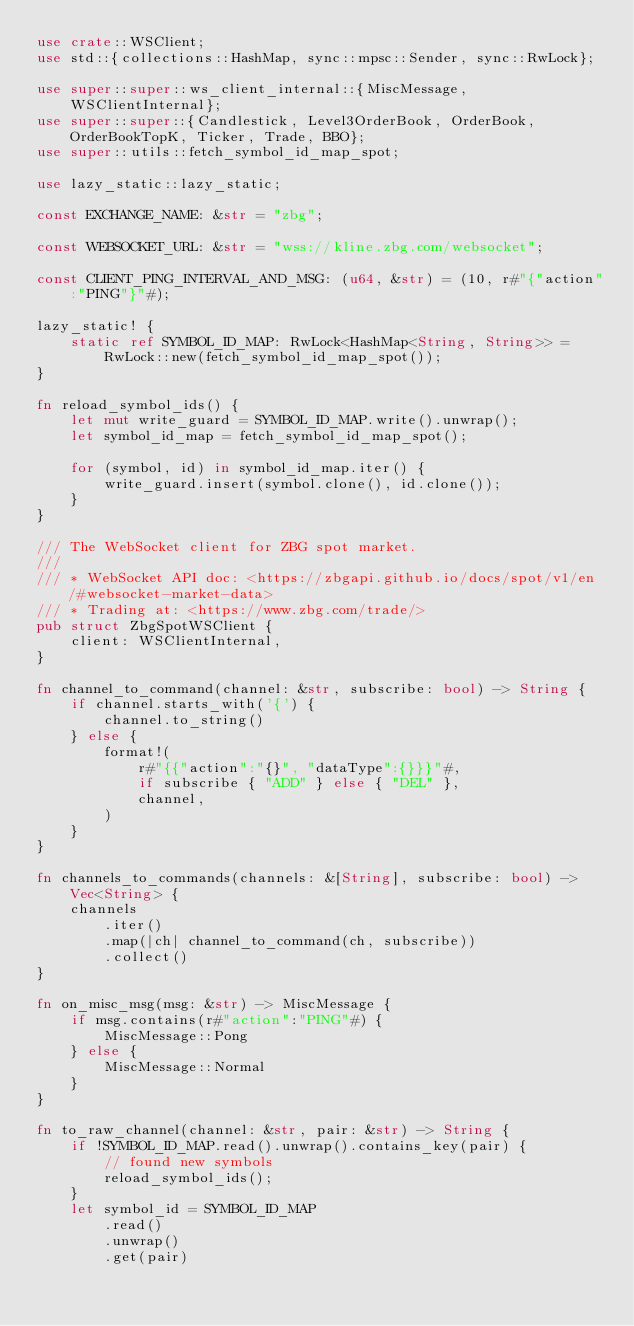Convert code to text. <code><loc_0><loc_0><loc_500><loc_500><_Rust_>use crate::WSClient;
use std::{collections::HashMap, sync::mpsc::Sender, sync::RwLock};

use super::super::ws_client_internal::{MiscMessage, WSClientInternal};
use super::super::{Candlestick, Level3OrderBook, OrderBook, OrderBookTopK, Ticker, Trade, BBO};
use super::utils::fetch_symbol_id_map_spot;

use lazy_static::lazy_static;

const EXCHANGE_NAME: &str = "zbg";

const WEBSOCKET_URL: &str = "wss://kline.zbg.com/websocket";

const CLIENT_PING_INTERVAL_AND_MSG: (u64, &str) = (10, r#"{"action":"PING"}"#);

lazy_static! {
    static ref SYMBOL_ID_MAP: RwLock<HashMap<String, String>> =
        RwLock::new(fetch_symbol_id_map_spot());
}

fn reload_symbol_ids() {
    let mut write_guard = SYMBOL_ID_MAP.write().unwrap();
    let symbol_id_map = fetch_symbol_id_map_spot();

    for (symbol, id) in symbol_id_map.iter() {
        write_guard.insert(symbol.clone(), id.clone());
    }
}

/// The WebSocket client for ZBG spot market.
///
/// * WebSocket API doc: <https://zbgapi.github.io/docs/spot/v1/en/#websocket-market-data>
/// * Trading at: <https://www.zbg.com/trade/>
pub struct ZbgSpotWSClient {
    client: WSClientInternal,
}

fn channel_to_command(channel: &str, subscribe: bool) -> String {
    if channel.starts_with('{') {
        channel.to_string()
    } else {
        format!(
            r#"{{"action":"{}", "dataType":{}}}"#,
            if subscribe { "ADD" } else { "DEL" },
            channel,
        )
    }
}

fn channels_to_commands(channels: &[String], subscribe: bool) -> Vec<String> {
    channels
        .iter()
        .map(|ch| channel_to_command(ch, subscribe))
        .collect()
}

fn on_misc_msg(msg: &str) -> MiscMessage {
    if msg.contains(r#"action":"PING"#) {
        MiscMessage::Pong
    } else {
        MiscMessage::Normal
    }
}

fn to_raw_channel(channel: &str, pair: &str) -> String {
    if !SYMBOL_ID_MAP.read().unwrap().contains_key(pair) {
        // found new symbols
        reload_symbol_ids();
    }
    let symbol_id = SYMBOL_ID_MAP
        .read()
        .unwrap()
        .get(pair)</code> 